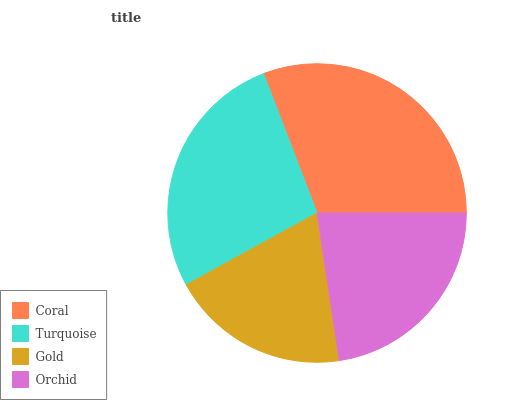Is Gold the minimum?
Answer yes or no. Yes. Is Coral the maximum?
Answer yes or no. Yes. Is Turquoise the minimum?
Answer yes or no. No. Is Turquoise the maximum?
Answer yes or no. No. Is Coral greater than Turquoise?
Answer yes or no. Yes. Is Turquoise less than Coral?
Answer yes or no. Yes. Is Turquoise greater than Coral?
Answer yes or no. No. Is Coral less than Turquoise?
Answer yes or no. No. Is Turquoise the high median?
Answer yes or no. Yes. Is Orchid the low median?
Answer yes or no. Yes. Is Coral the high median?
Answer yes or no. No. Is Coral the low median?
Answer yes or no. No. 